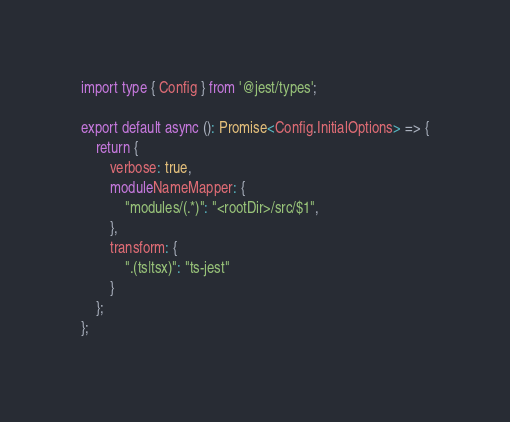<code> <loc_0><loc_0><loc_500><loc_500><_TypeScript_>import type { Config } from '@jest/types';

export default async (): Promise<Config.InitialOptions> => {
    return {
        verbose: true,
        moduleNameMapper: {
            "modules/(.*)": "<rootDir>/src/$1",
        },
        transform: {
            ".(ts|tsx)": "ts-jest"
        }
    };
};</code> 